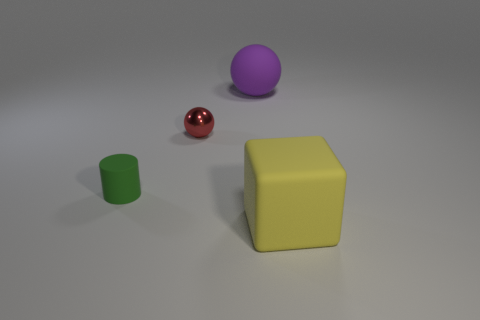There is a object that is behind the cylinder and in front of the purple ball; what color is it?
Keep it short and to the point. Red. What is the large object that is behind the tiny matte cylinder made of?
Offer a very short reply. Rubber. What is the size of the yellow cube?
Offer a very short reply. Large. How many green objects are either tiny cylinders or blocks?
Your answer should be very brief. 1. There is a rubber object that is left of the small object behind the tiny matte object; what size is it?
Your answer should be very brief. Small. What number of other objects are there of the same material as the small red ball?
Keep it short and to the point. 0. What is the shape of the big purple object that is made of the same material as the large yellow thing?
Provide a succinct answer. Sphere. Are there any other things of the same color as the metallic sphere?
Provide a succinct answer. No. Are there more small objects that are right of the cylinder than metallic blocks?
Your answer should be very brief. Yes. There is a red thing; is it the same shape as the large rubber object behind the small cylinder?
Offer a terse response. Yes. 